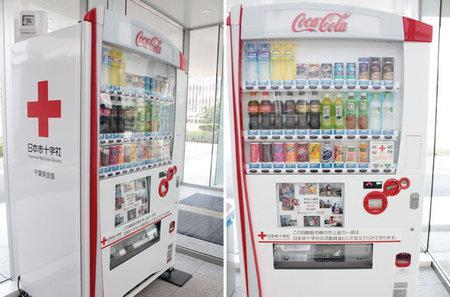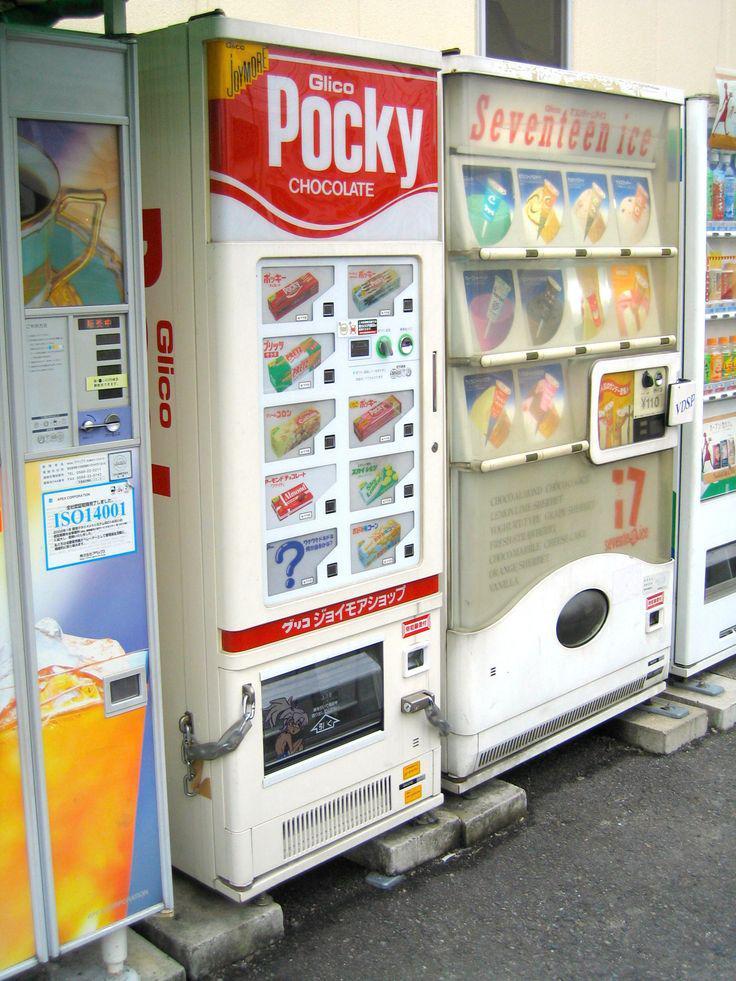The first image is the image on the left, the second image is the image on the right. For the images displayed, is the sentence "One of the vending machines sells condoms." factually correct? Answer yes or no. No. The first image is the image on the left, the second image is the image on the right. Examine the images to the left and right. Is the description "One of the machines has a red cross on it." accurate? Answer yes or no. Yes. 